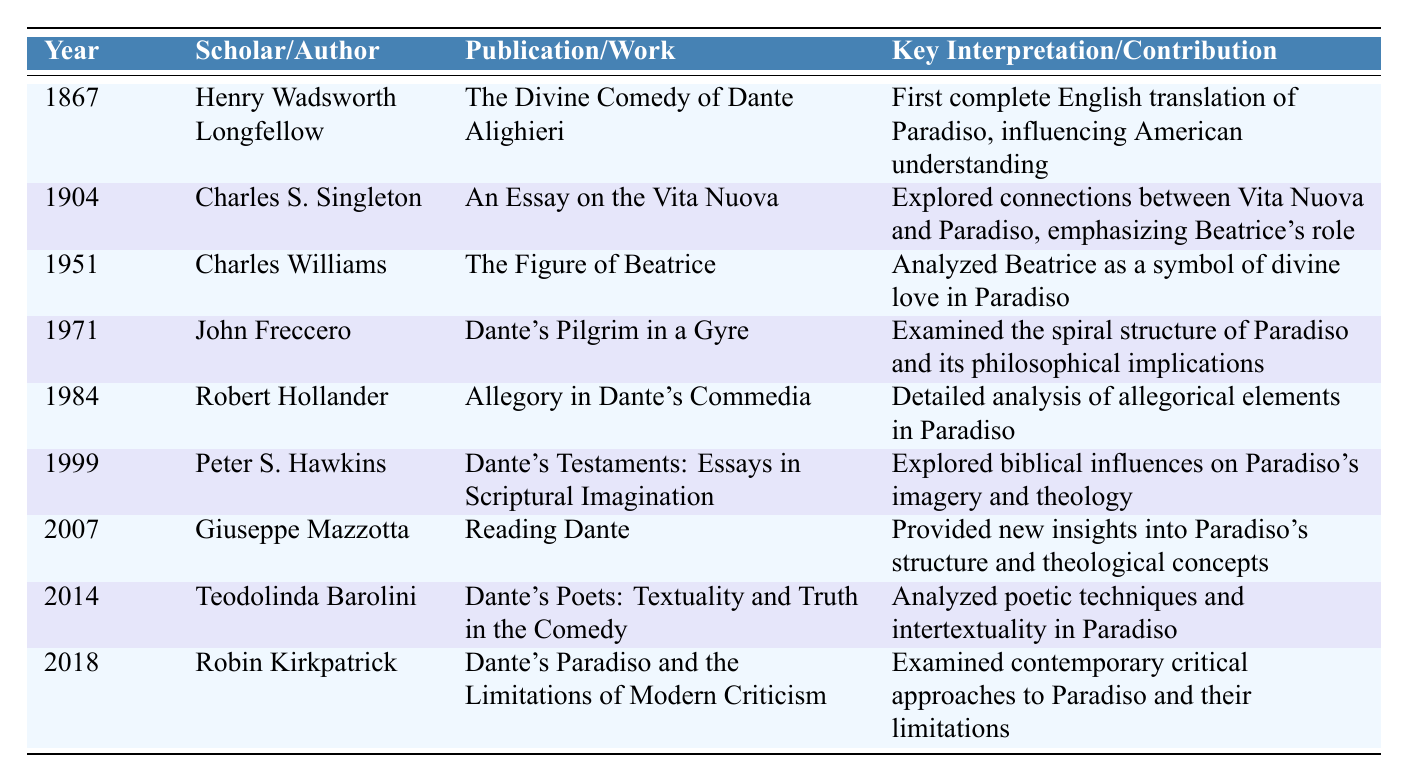What year was the first complete English translation of Paradiso published? The first complete English translation of Paradiso was done by Henry Wadsworth Longfellow in 1867. This can be found in the "Year" column corresponding to Longfellow's name.
Answer: 1867 Who wrote "Dante's Testaments: Essays in Scriptural Imagination"? The author of "Dante's Testaments: Essays in Scriptural Imagination" is Peter S. Hawkins, as indicated in the "Scholar/Author" column next to the corresponding publication.
Answer: Peter S. Hawkins Which publication discussed Beatrice's role in both the Vita Nuova and Paradiso? The publication that discussed Beatrice's role is "An Essay on the Vita Nuova" written by Charles S. Singleton in 1904. This is clear from the "Key Interpretation/Contribution" column.
Answer: An Essay on the Vita Nuova How many publications listed were authored by Charles Williams or John Freccero? Charles Williams has one publication, "The Figure of Beatrice," and John Freccero has one, "Dante's Pilgrim in a Gyre." Adding these gives a total of 2.
Answer: 2 Which scholar provided insights into the structure and theological concepts of Paradiso in 2007? Giuseppe Mazzotta published "Reading Dante" in 2007, and the table shows that he provided insights into the structure and theological concepts of Paradiso.
Answer: Giuseppe Mazzotta What was the key contribution of Robert Hollander's publication? Robert Hollander's "Allegory in Dante's Commedia" analyzed the allegorical elements in Paradiso. This is reflected in the "Key Interpretation/Contribution" column next to his publication entry.
Answer: Detailed analysis of allegorical elements in Paradiso Is the publication "Dante's Paradiso and the Limitations of Modern Criticism" focused on outdated critical approaches? No, the publication by Robin Kirkpatrick examines contemporary critical approaches to Paradiso and their limitations, not outdated ones. This can be seen from the description under "Key Interpretation/Contribution."
Answer: No What is the latest year mentioned in the table for a publication related to Paradiso? The latest year listed in the table is 2018, corresponding to Robin Kirkpatrick's publication. This can be identified by looking at the last entry in the "Year" column.
Answer: 2018 Did any of the scholars focus on the biblical influences in Paradiso? Yes, Peter S. Hawkins in his 1999 publication "Dante's Testaments: Essays in Scriptural Imagination" explored biblical influences on Paradiso's imagery and theology, as noted in the "Key Interpretation/Contribution."
Answer: Yes What is the difference in publication years between the translation by Longfellow and the analysis by Barolini? Longfellow published his translation in 1867, and Barolini's analysis was published in 2014. The difference in years is 2014 - 1867 = 147 years.
Answer: 147 years How many different themes are explored by the scholars in the table? The themes explored include translation, the role of Beatrice, allegory, structure, biblical influences, theological concepts, poetic techniques, and critical approaches. Counting these gives a total of 8 different themes.
Answer: 8 